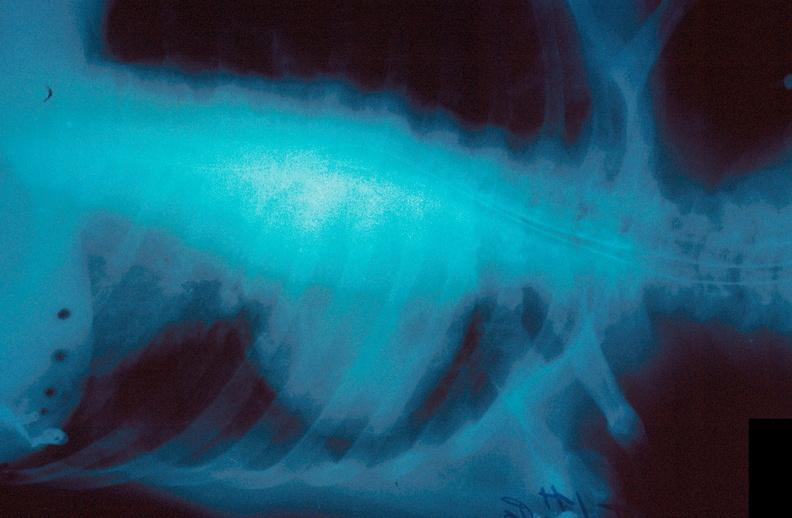does senile plaque show lung, hematoma?
Answer the question using a single word or phrase. No 